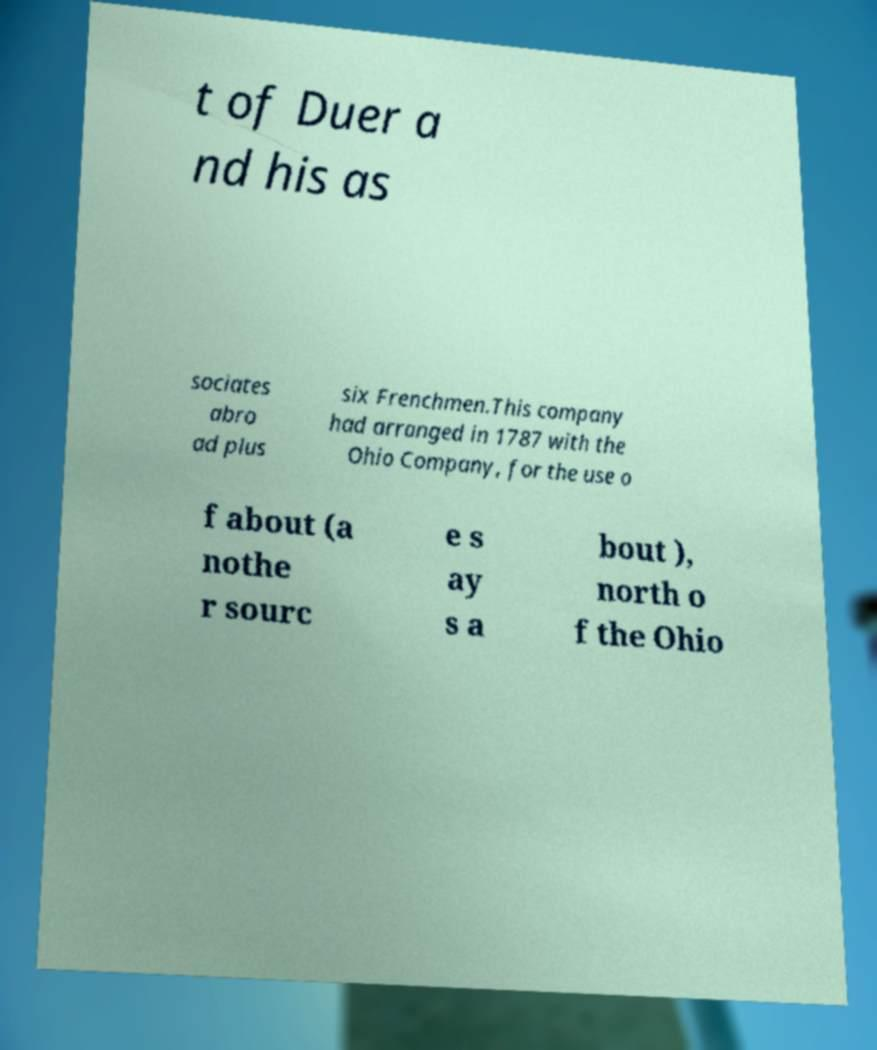Please identify and transcribe the text found in this image. t of Duer a nd his as sociates abro ad plus six Frenchmen.This company had arranged in 1787 with the Ohio Company, for the use o f about (a nothe r sourc e s ay s a bout ), north o f the Ohio 